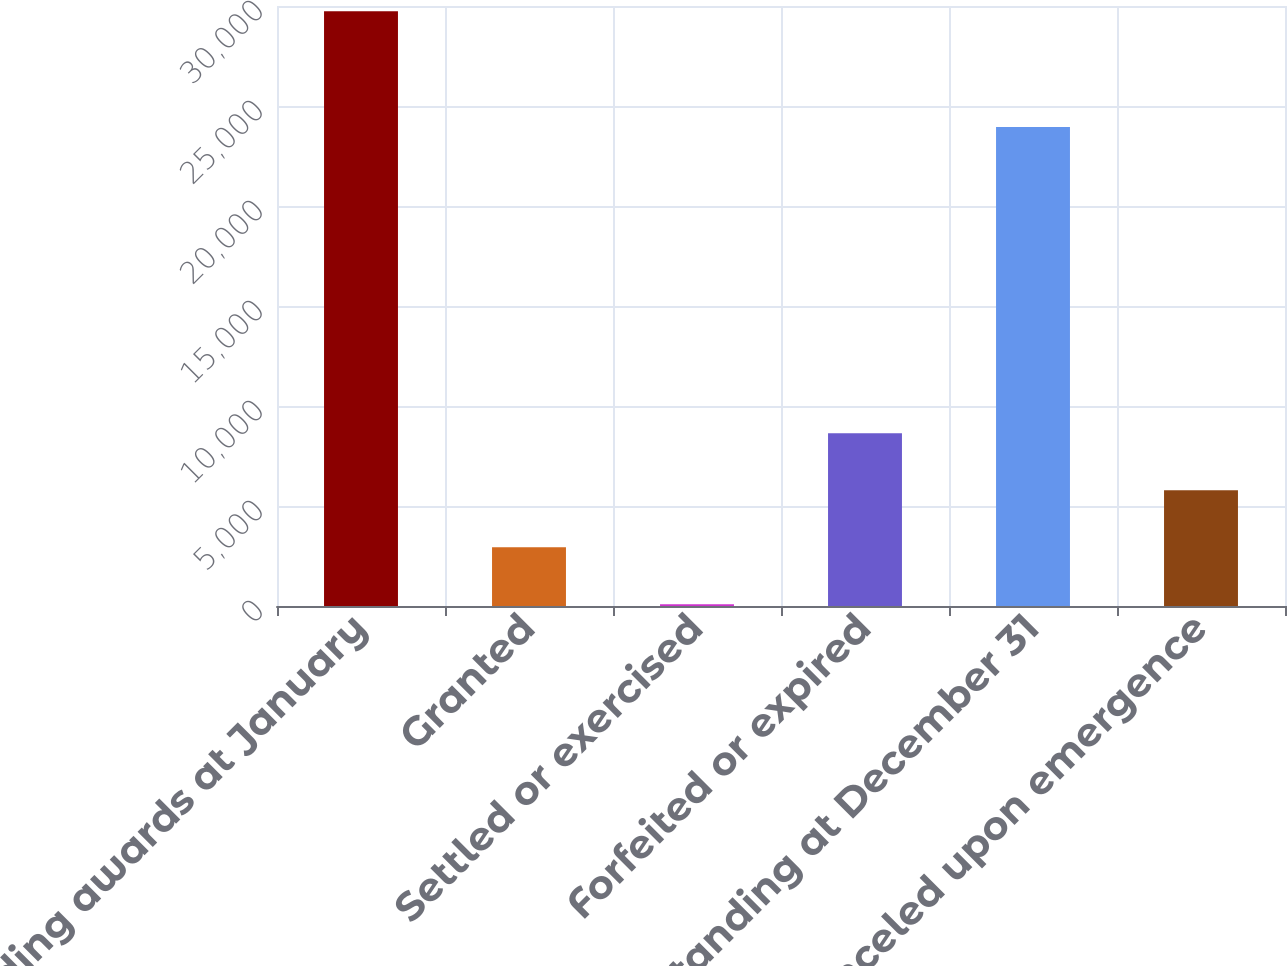<chart> <loc_0><loc_0><loc_500><loc_500><bar_chart><fcel>Outstanding awards at January<fcel>Granted<fcel>Settled or exercised<fcel>Forfeited or expired<fcel>Outstanding at December 31<fcel>Canceled upon emergence<nl><fcel>29743.3<fcel>2940.3<fcel>90<fcel>8640.9<fcel>23950<fcel>5790.6<nl></chart> 